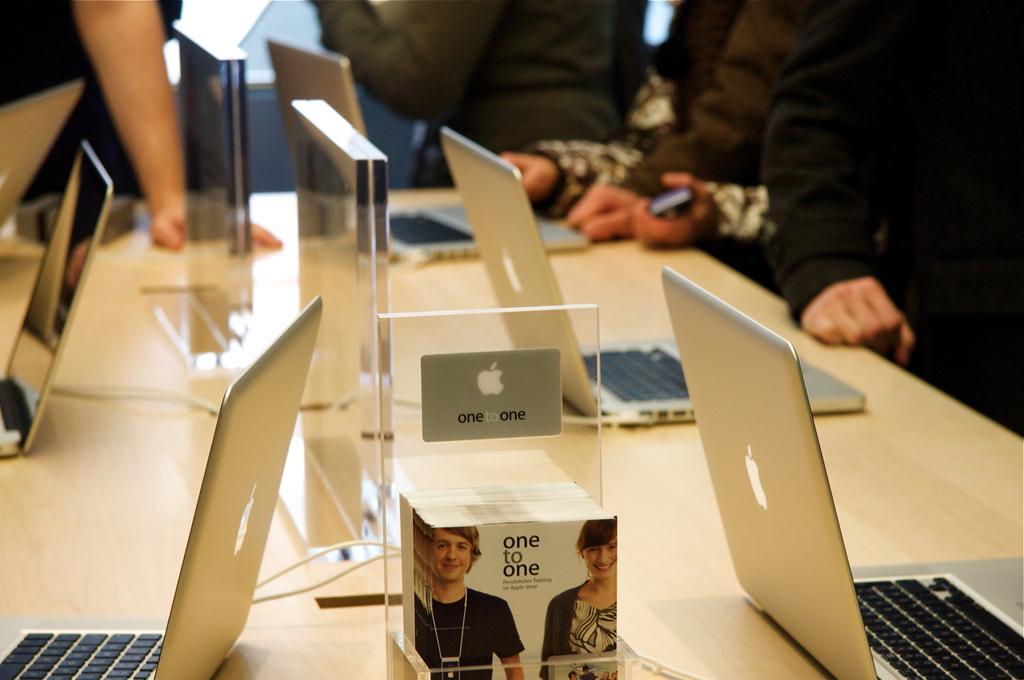Describe this image in one or two sentences. There are people where the table is present in front of them and mac books are present on the table and some notepads also there. 